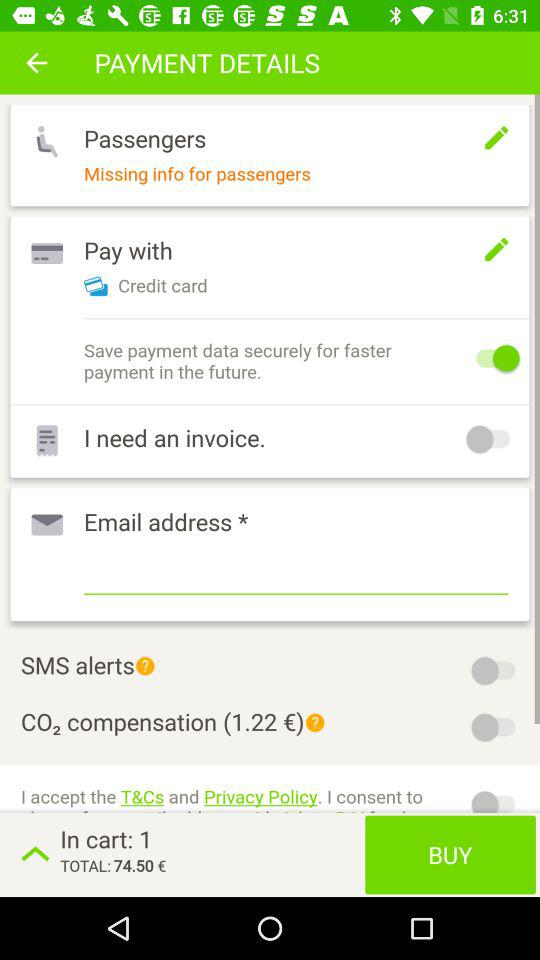What is the status of "Save payment data securely for faster payment in the future"? The status is "on". 